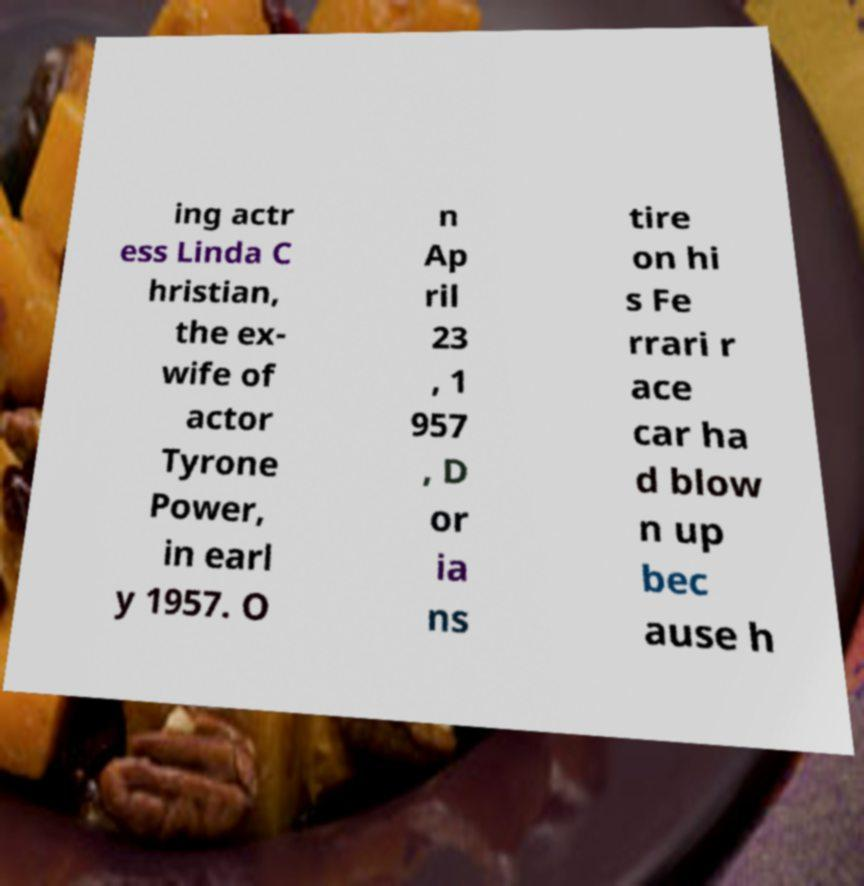Please identify and transcribe the text found in this image. ing actr ess Linda C hristian, the ex- wife of actor Tyrone Power, in earl y 1957. O n Ap ril 23 , 1 957 , D or ia ns tire on hi s Fe rrari r ace car ha d blow n up bec ause h 